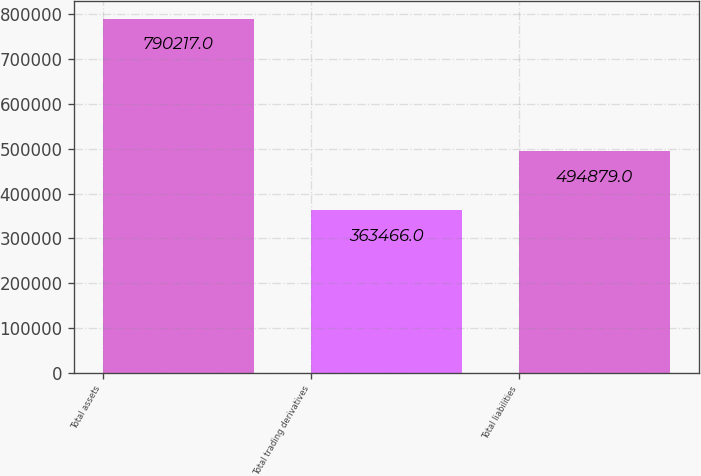<chart> <loc_0><loc_0><loc_500><loc_500><bar_chart><fcel>Total assets<fcel>Total trading derivatives<fcel>Total liabilities<nl><fcel>790217<fcel>363466<fcel>494879<nl></chart> 